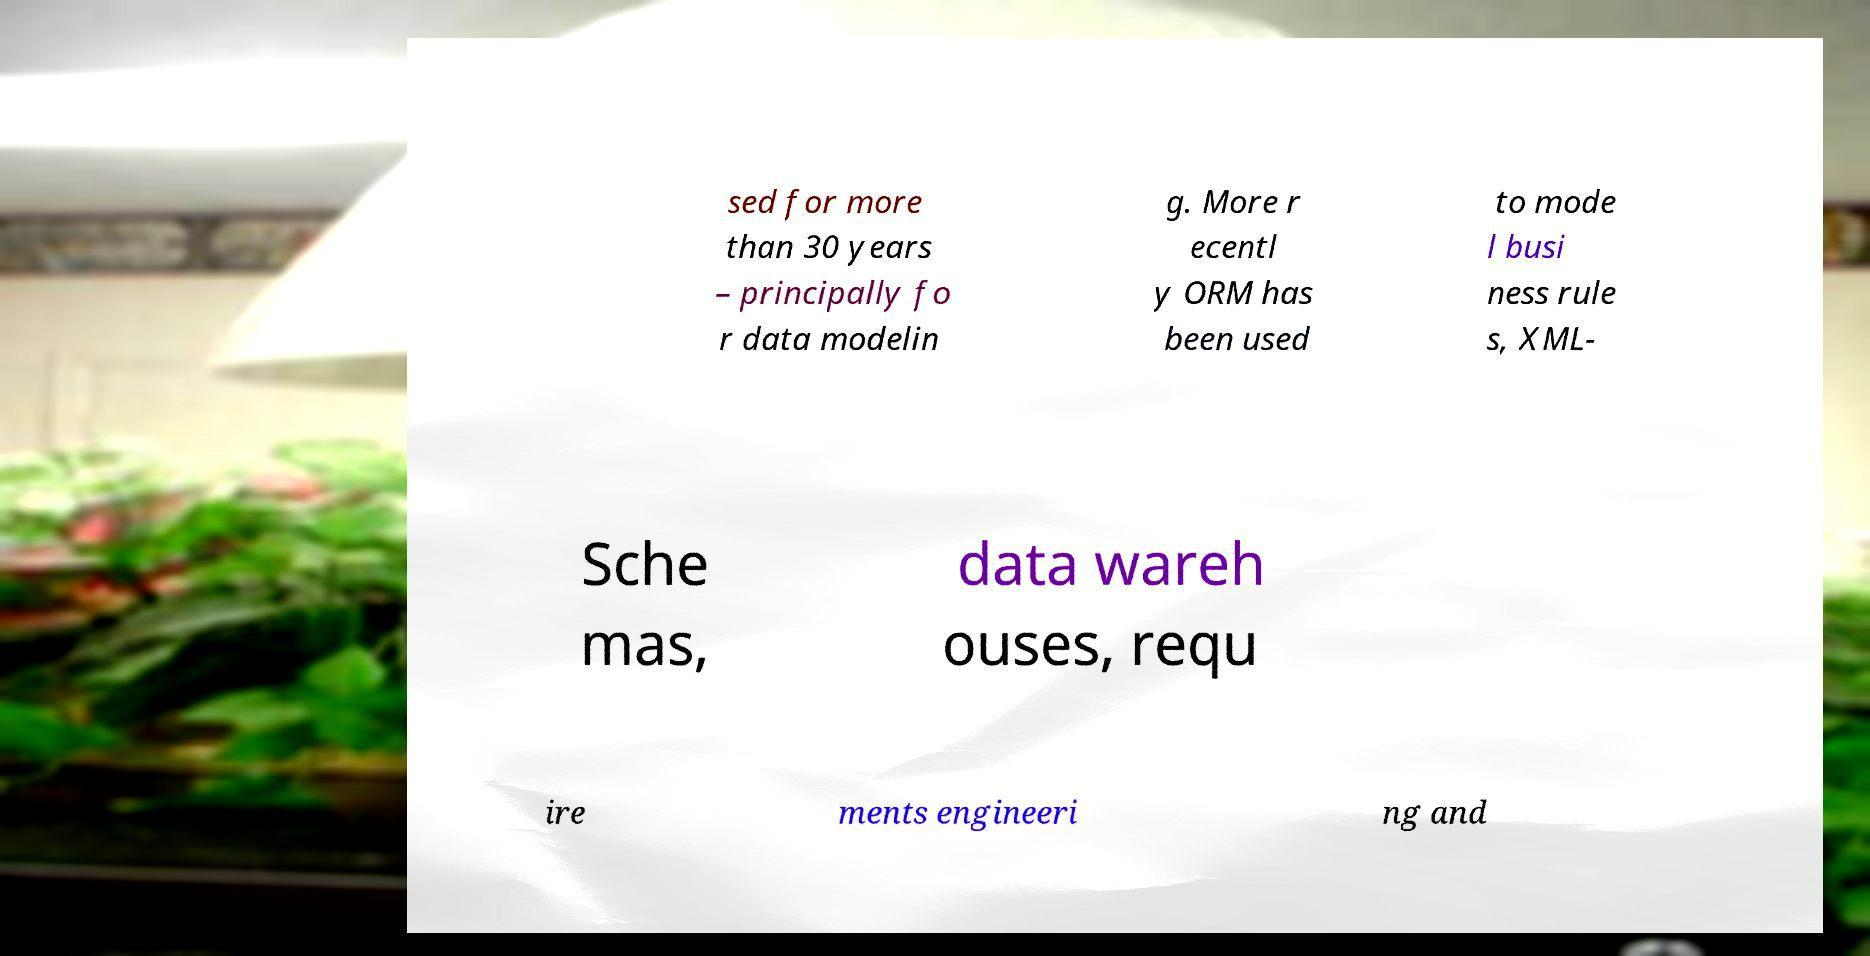For documentation purposes, I need the text within this image transcribed. Could you provide that? sed for more than 30 years – principally fo r data modelin g. More r ecentl y ORM has been used to mode l busi ness rule s, XML- Sche mas, data wareh ouses, requ ire ments engineeri ng and 